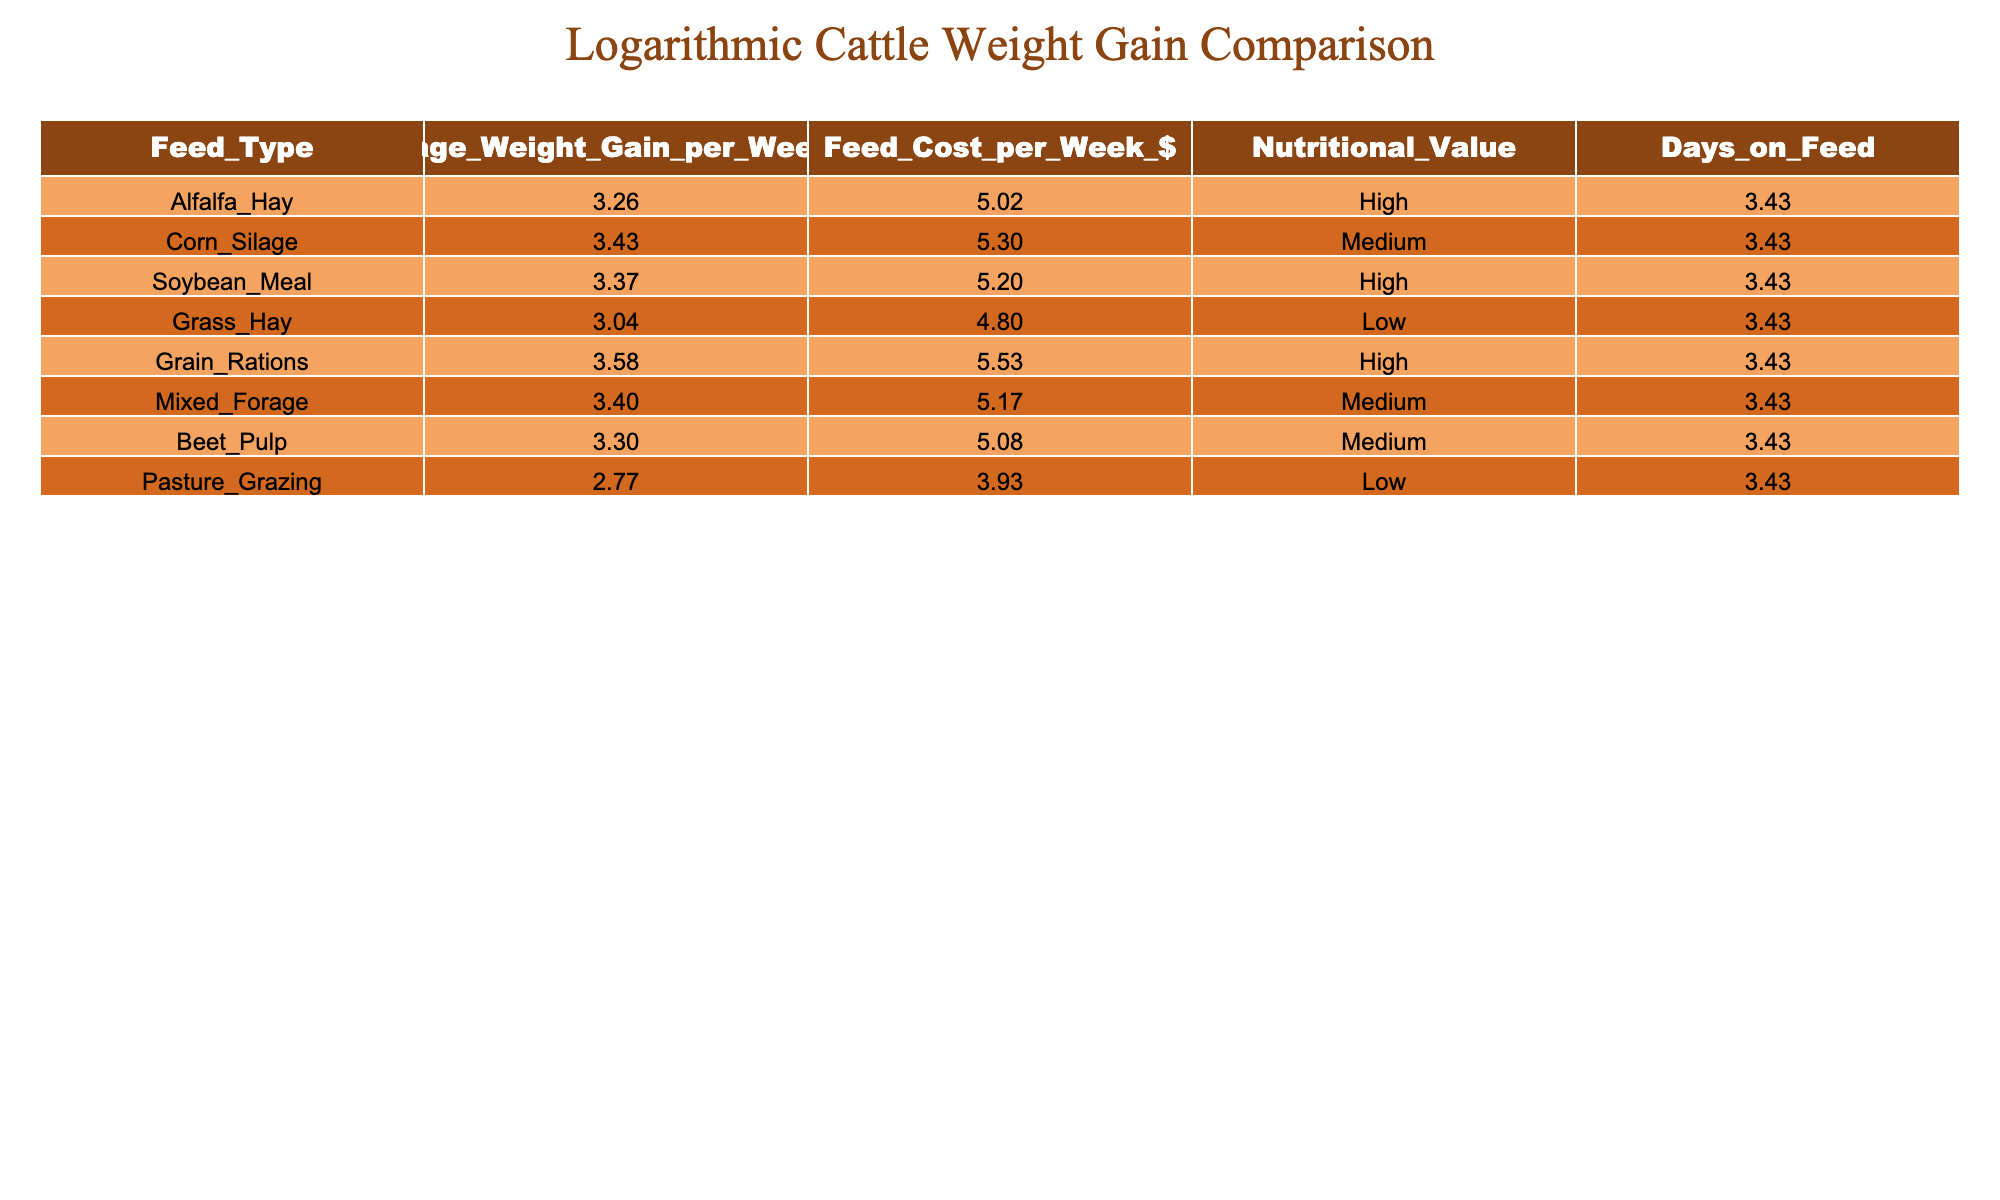What is the average weight gain per week for cattle fed with Grain Rations? The table directly lists the average weight gain per week for each feed type. For Grain Rations, the value is 35 lbs.
Answer: 35 lbs Which feed type has the lowest feed cost per week? The table shows the feed cost per week for each type. Pasture Grazing has the lowest cost at $50.
Answer: $50 Which feed type provides the highest nutritional value? The table shows that Alfalfa Hay, Soybean Meal, Grain Rations, and Beet Pulp all have a "High" nutritional value.
Answer: Alfalfa Hay, Soybean Meal, Grain Rations, Beet Pulp What is the difference in average weight gain per week between Corn Silage and Grass Hay? For Corn Silage, the average weight gain is 30 lbs, and for Grass Hay, it is 20 lbs. The difference is 30 - 20 = 10 lbs.
Answer: 10 lbs Is the feed cost for Mixed Forage higher than for Alfalfa Hay? The table indicates that Mixed Forage costs $175 per week, whereas Alfalfa Hay costs $150. Therefore, Mixed Forage does have a higher cost.
Answer: Yes What is the total average weight gain for all feed types combined? Adding the average weight gains of all feed types: 25 + 30 + 28 + 20 + 35 + 29 + 26 + 15 =  31.5 lbs (on average). There are 8 feed types, so the total average gain would be 31.5 / 8 = 23.75 lbs.
Answer: 23.75 lbs For how many days is the cattle fed each type of feed? The table specifies that all the feed types are maintained for 30 days, which is uniform across the board.
Answer: 30 days Does Corn Silage have a higher average weight gain than Pasture Grazing? From the table, Corn Silage has an average weight gain of 30 lbs, while Pasture Grazing has 15 lbs. Therefore, Corn Silage does have a higher average gain.
Answer: Yes What is the nutritional value of the feed type that has the highest weekly average weight gain? Grain Rations provide the highest weekly average weight gain of 35 lbs, and its nutritional value is classified as "High."
Answer: High 